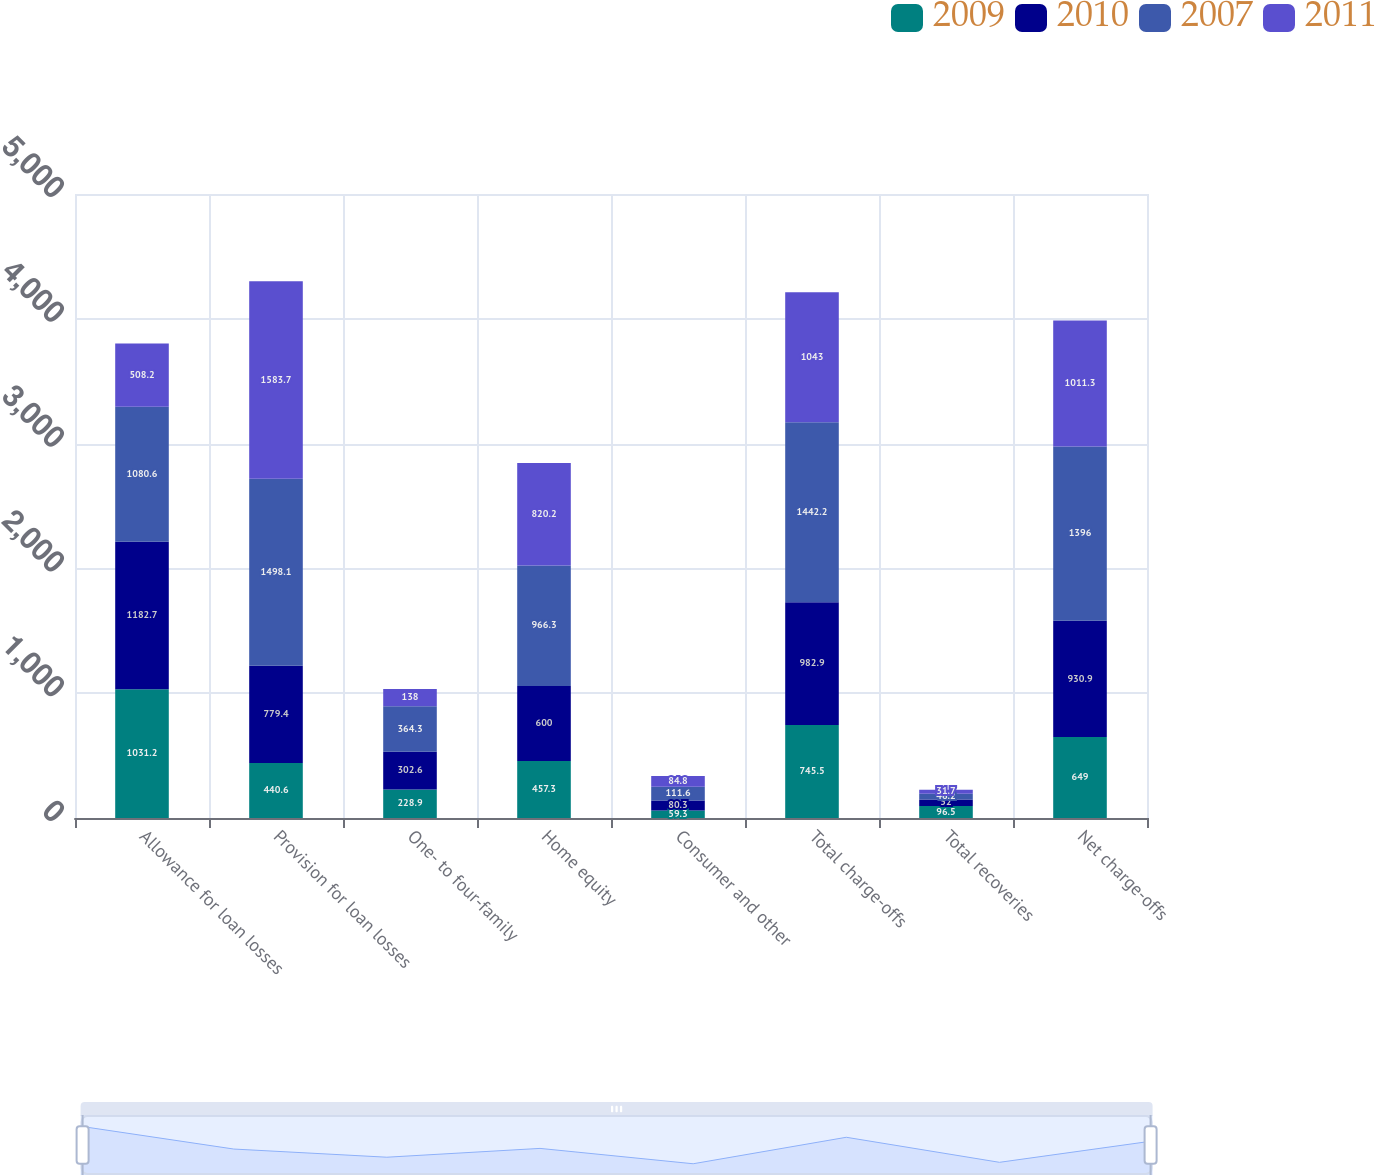Convert chart. <chart><loc_0><loc_0><loc_500><loc_500><stacked_bar_chart><ecel><fcel>Allowance for loan losses<fcel>Provision for loan losses<fcel>One- to four-family<fcel>Home equity<fcel>Consumer and other<fcel>Total charge-offs<fcel>Total recoveries<fcel>Net charge-offs<nl><fcel>2009<fcel>1031.2<fcel>440.6<fcel>228.9<fcel>457.3<fcel>59.3<fcel>745.5<fcel>96.5<fcel>649<nl><fcel>2010<fcel>1182.7<fcel>779.4<fcel>302.6<fcel>600<fcel>80.3<fcel>982.9<fcel>52<fcel>930.9<nl><fcel>2007<fcel>1080.6<fcel>1498.1<fcel>364.3<fcel>966.3<fcel>111.6<fcel>1442.2<fcel>46.2<fcel>1396<nl><fcel>2011<fcel>508.2<fcel>1583.7<fcel>138<fcel>820.2<fcel>84.8<fcel>1043<fcel>31.7<fcel>1011.3<nl></chart> 